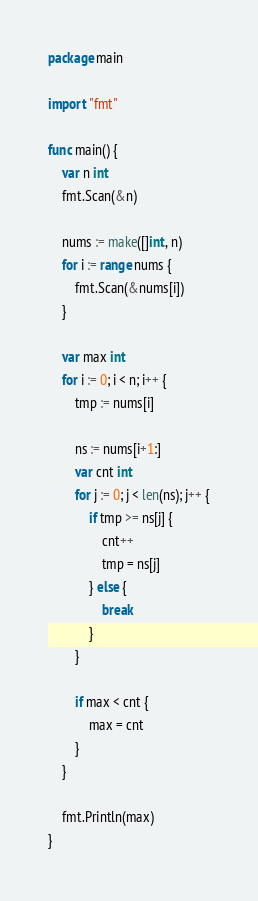Convert code to text. <code><loc_0><loc_0><loc_500><loc_500><_Go_>package main

import "fmt"

func main() {
	var n int
	fmt.Scan(&n)

	nums := make([]int, n)
	for i := range nums {
		fmt.Scan(&nums[i])
	}

	var max int
	for i := 0; i < n; i++ {
		tmp := nums[i]

		ns := nums[i+1:]
		var cnt int
		for j := 0; j < len(ns); j++ {
			if tmp >= ns[j] {
				cnt++
				tmp = ns[j]
			} else {
				break
			}
		}

		if max < cnt {
			max = cnt
		}
	}

	fmt.Println(max)
}
</code> 